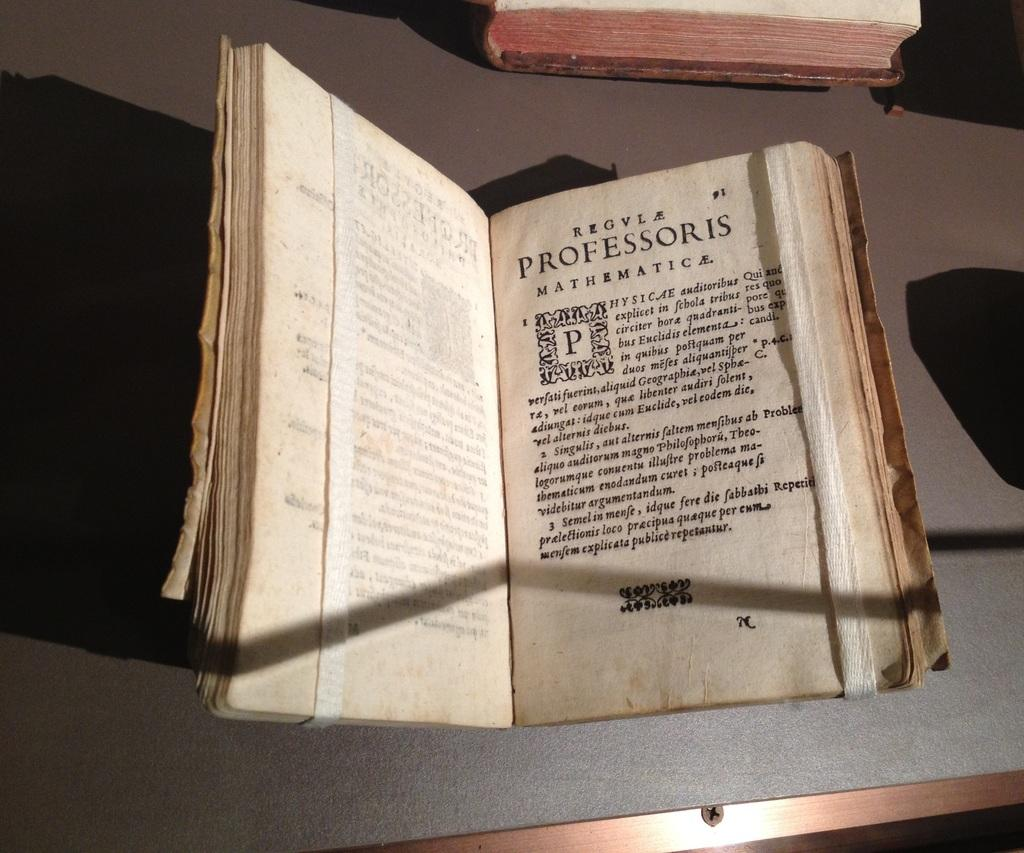<image>
Provide a brief description of the given image. An old worn book made for a professor of mathematics. 